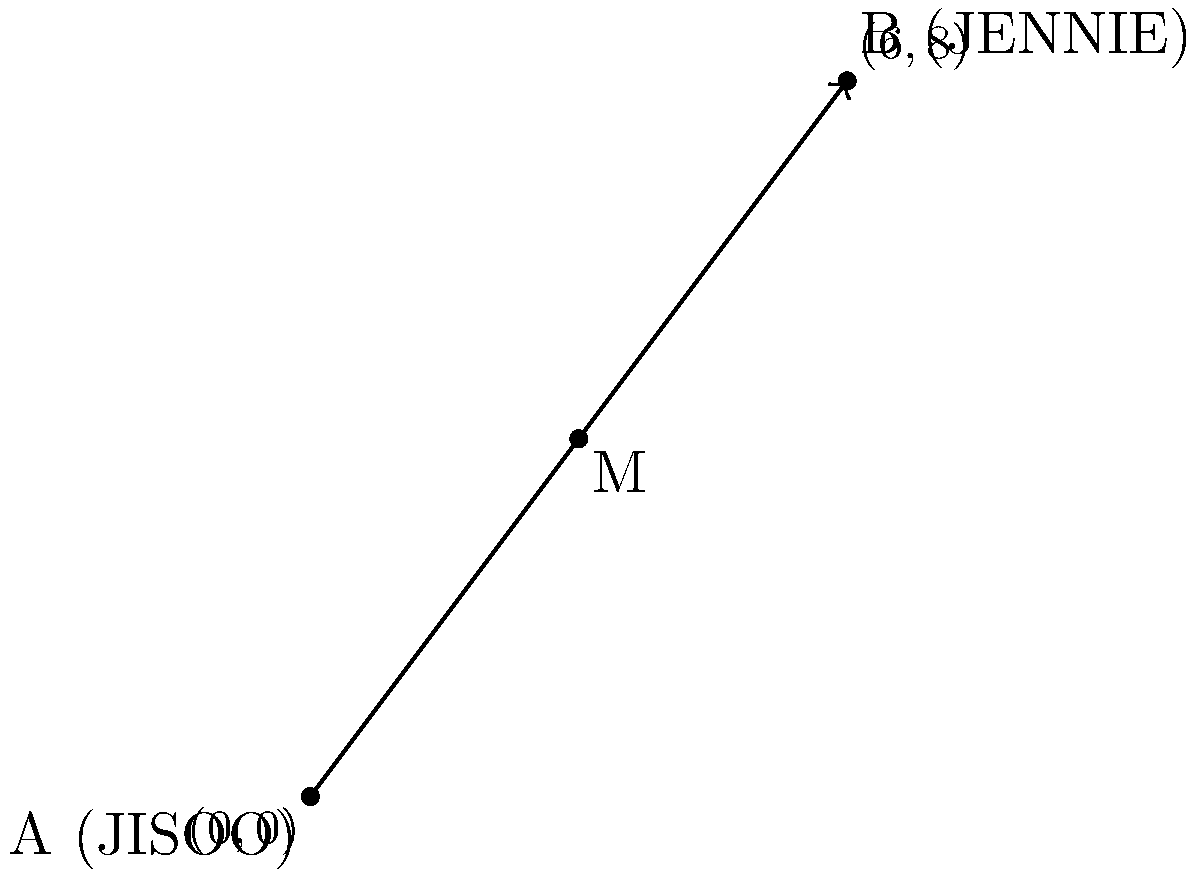In a BLACKPINK dance formation, JISOO is positioned at $(0,0)$ and JENNIE is at $(6,8)$. What are the coordinates of the midpoint between their positions? (Hint: This point might be where ROSÉ or LISA could stand to balance the formation.) To find the midpoint between two points, we can use the midpoint formula:

$$ M_x = \frac{x_1 + x_2}{2}, \quad M_y = \frac{y_1 + y_2}{2} $$

Where $(x_1, y_1)$ is the position of JISOO and $(x_2, y_2)$ is the position of JENNIE.

Step 1: Identify the coordinates
JISOO: $(x_1, y_1) = (0, 0)$
JENNIE: $(x_2, y_2) = (6, 8)$

Step 2: Calculate the x-coordinate of the midpoint
$$ M_x = \frac{x_1 + x_2}{2} = \frac{0 + 6}{2} = \frac{6}{2} = 3 $$

Step 3: Calculate the y-coordinate of the midpoint
$$ M_y = \frac{y_1 + y_2}{2} = \frac{0 + 8}{2} = \frac{8}{2} = 4 $$

Step 4: Combine the results
The midpoint M has coordinates $(M_x, M_y) = (3, 4)$

This point $(3, 4)$ represents where ROSÉ or LISA could potentially stand to balance the formation between JISOO and JENNIE.
Answer: $(3, 4)$ 